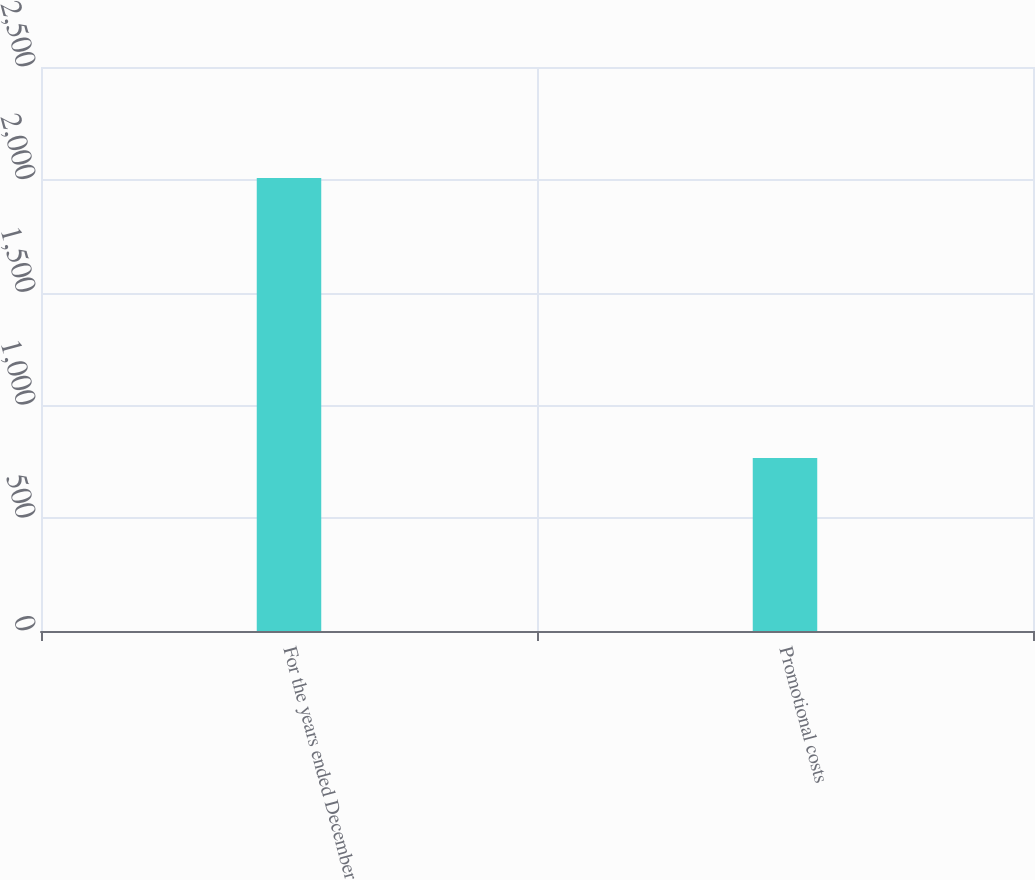<chart> <loc_0><loc_0><loc_500><loc_500><bar_chart><fcel>For the years ended December<fcel>Promotional costs<nl><fcel>2008<fcel>766.6<nl></chart> 